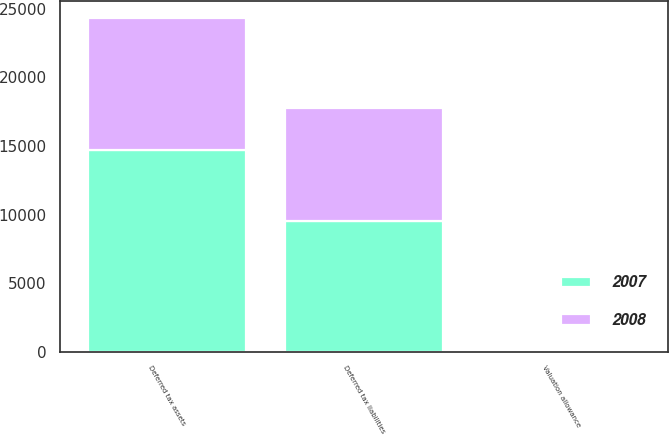Convert chart to OTSL. <chart><loc_0><loc_0><loc_500><loc_500><stacked_bar_chart><ecel><fcel>Deferred tax assets<fcel>Deferred tax liabilities<fcel>Valuation allowance<nl><fcel>2007<fcel>14700<fcel>9492<fcel>48<nl><fcel>2008<fcel>9640<fcel>8272<fcel>20<nl></chart> 